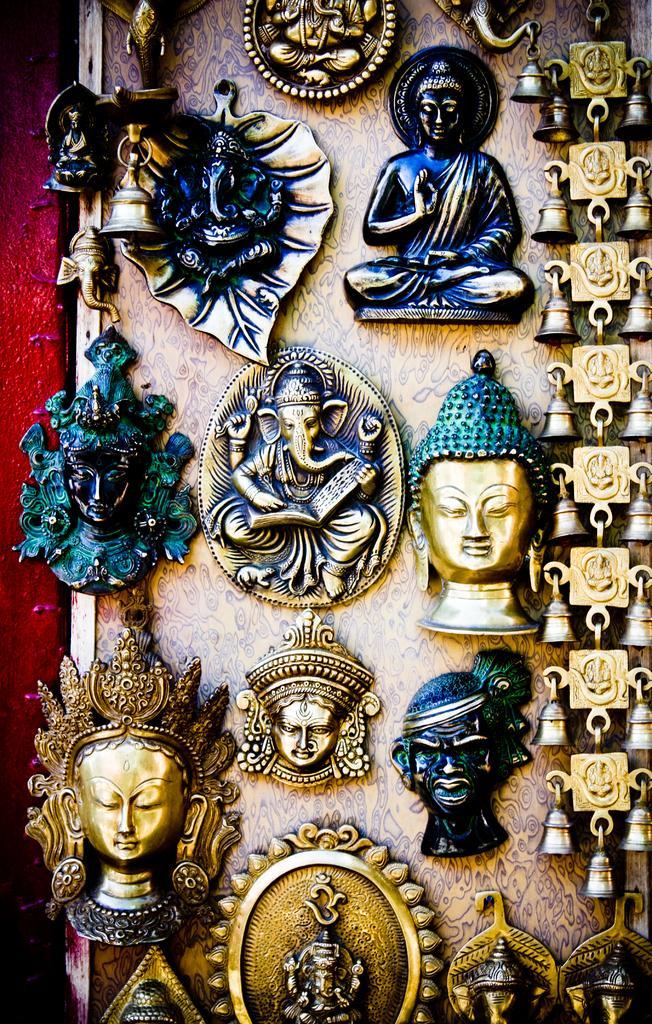In one or two sentences, can you explain what this image depicts? Here I can see few idols are attached a wall. 